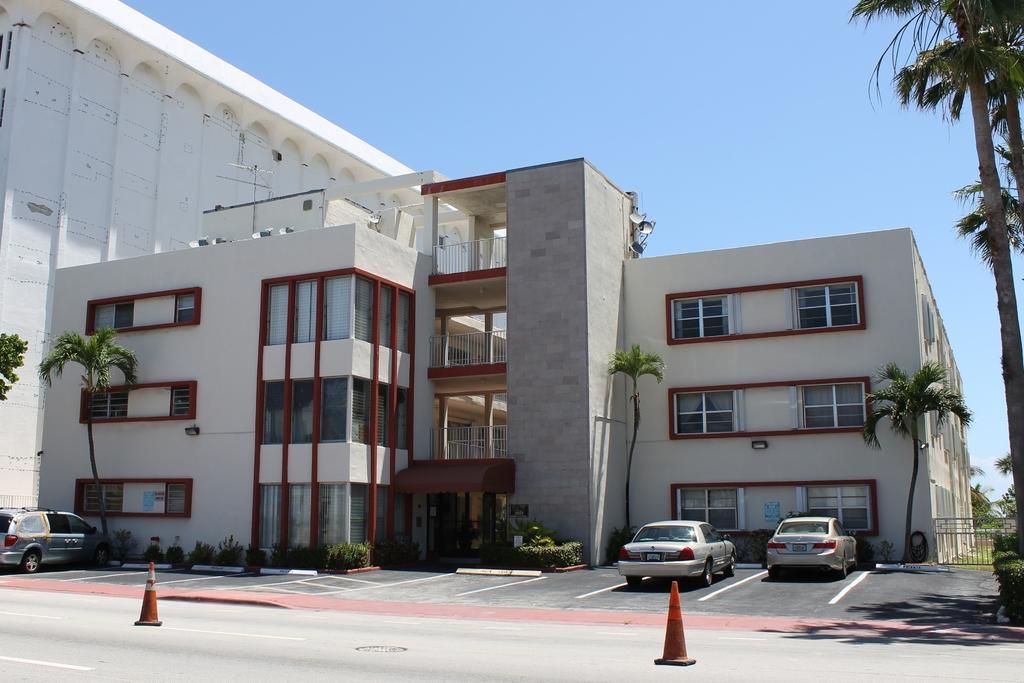Can you describe this image briefly? In this picture, we can see three cars parked on the path and behind the cars there are cone barriers and in front of the vehicles there are trees, plants, building and a sky. 